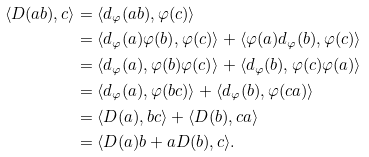Convert formula to latex. <formula><loc_0><loc_0><loc_500><loc_500>\langle D ( a b ) , c \rangle & = \langle d _ { \varphi } ( a b ) , \varphi ( c ) \rangle \\ & = \langle d _ { \varphi } ( a ) \varphi ( b ) , \varphi ( c ) \rangle + \langle \varphi ( a ) d _ { \varphi } ( b ) , \varphi ( c ) \rangle \\ & = \langle d _ { \varphi } ( a ) , \varphi ( b ) \varphi ( c ) \rangle + \langle d _ { \varphi } ( b ) , \varphi ( c ) \varphi ( a ) \rangle \\ & = \langle d _ { \varphi } ( a ) , \varphi ( b c ) \rangle + \langle d _ { \varphi } ( b ) , \varphi ( c a ) \rangle \\ & = \langle D ( a ) , b c \rangle + \langle D ( b ) , c a \rangle \\ & = \langle D ( a ) b + a D ( b ) , c \rangle .</formula> 